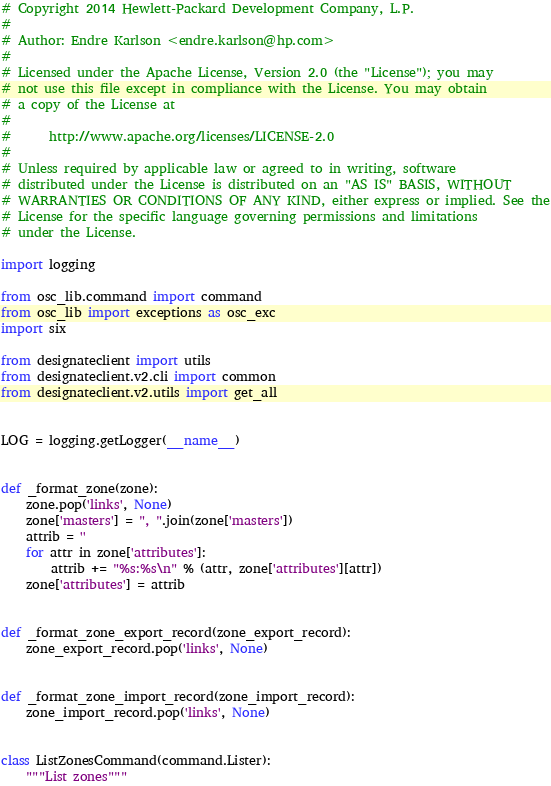<code> <loc_0><loc_0><loc_500><loc_500><_Python_># Copyright 2014 Hewlett-Packard Development Company, L.P.
#
# Author: Endre Karlson <endre.karlson@hp.com>
#
# Licensed under the Apache License, Version 2.0 (the "License"); you may
# not use this file except in compliance with the License. You may obtain
# a copy of the License at
#
#      http://www.apache.org/licenses/LICENSE-2.0
#
# Unless required by applicable law or agreed to in writing, software
# distributed under the License is distributed on an "AS IS" BASIS, WITHOUT
# WARRANTIES OR CONDITIONS OF ANY KIND, either express or implied. See the
# License for the specific language governing permissions and limitations
# under the License.

import logging

from osc_lib.command import command
from osc_lib import exceptions as osc_exc
import six

from designateclient import utils
from designateclient.v2.cli import common
from designateclient.v2.utils import get_all


LOG = logging.getLogger(__name__)


def _format_zone(zone):
    zone.pop('links', None)
    zone['masters'] = ", ".join(zone['masters'])
    attrib = ''
    for attr in zone['attributes']:
        attrib += "%s:%s\n" % (attr, zone['attributes'][attr])
    zone['attributes'] = attrib


def _format_zone_export_record(zone_export_record):
    zone_export_record.pop('links', None)


def _format_zone_import_record(zone_import_record):
    zone_import_record.pop('links', None)


class ListZonesCommand(command.Lister):
    """List zones"""
</code> 